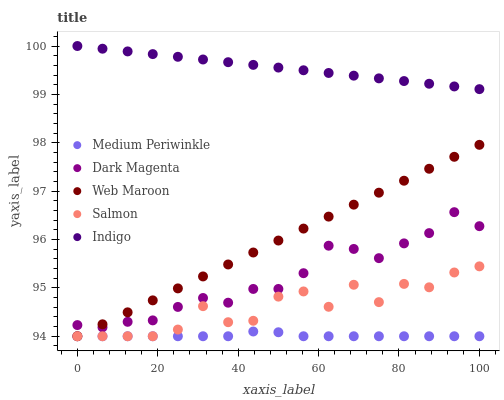Does Medium Periwinkle have the minimum area under the curve?
Answer yes or no. Yes. Does Indigo have the maximum area under the curve?
Answer yes or no. Yes. Does Dark Magenta have the minimum area under the curve?
Answer yes or no. No. Does Dark Magenta have the maximum area under the curve?
Answer yes or no. No. Is Indigo the smoothest?
Answer yes or no. Yes. Is Salmon the roughest?
Answer yes or no. Yes. Is Medium Periwinkle the smoothest?
Answer yes or no. No. Is Medium Periwinkle the roughest?
Answer yes or no. No. Does Web Maroon have the lowest value?
Answer yes or no. Yes. Does Dark Magenta have the lowest value?
Answer yes or no. No. Does Indigo have the highest value?
Answer yes or no. Yes. Does Dark Magenta have the highest value?
Answer yes or no. No. Is Salmon less than Dark Magenta?
Answer yes or no. Yes. Is Indigo greater than Medium Periwinkle?
Answer yes or no. Yes. Does Web Maroon intersect Medium Periwinkle?
Answer yes or no. Yes. Is Web Maroon less than Medium Periwinkle?
Answer yes or no. No. Is Web Maroon greater than Medium Periwinkle?
Answer yes or no. No. Does Salmon intersect Dark Magenta?
Answer yes or no. No. 